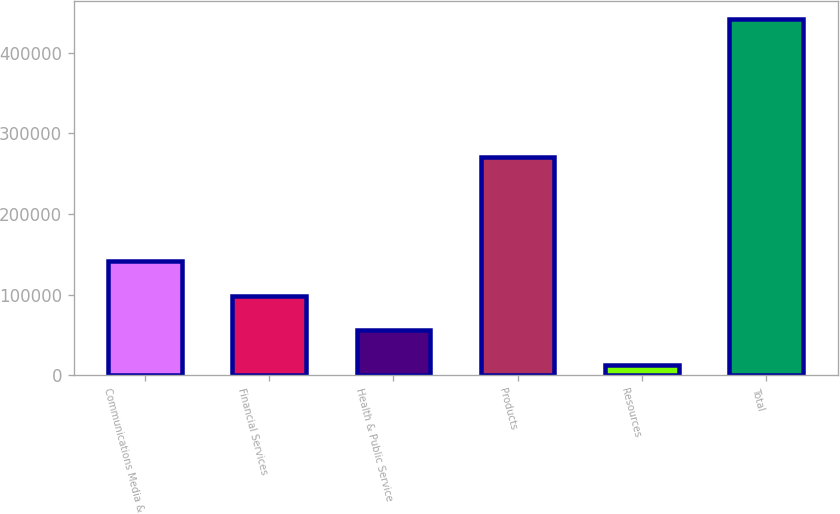Convert chart to OTSL. <chart><loc_0><loc_0><loc_500><loc_500><bar_chart><fcel>Communications Media &<fcel>Financial Services<fcel>Health & Public Service<fcel>Products<fcel>Resources<fcel>Total<nl><fcel>141902<fcel>98989<fcel>56076<fcel>270701<fcel>13163<fcel>442293<nl></chart> 